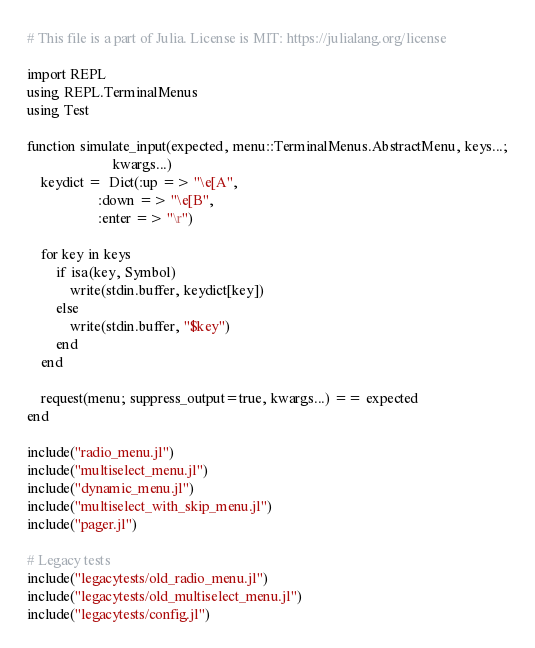Convert code to text. <code><loc_0><loc_0><loc_500><loc_500><_Julia_># This file is a part of Julia. License is MIT: https://julialang.org/license

import REPL
using REPL.TerminalMenus
using Test

function simulate_input(expected, menu::TerminalMenus.AbstractMenu, keys...;
                        kwargs...)
    keydict =  Dict(:up => "\e[A",
                    :down => "\e[B",
                    :enter => "\r")

    for key in keys
        if isa(key, Symbol)
            write(stdin.buffer, keydict[key])
        else
            write(stdin.buffer, "$key")
        end
    end

    request(menu; suppress_output=true, kwargs...) == expected
end

include("radio_menu.jl")
include("multiselect_menu.jl")
include("dynamic_menu.jl")
include("multiselect_with_skip_menu.jl")
include("pager.jl")

# Legacy tests
include("legacytests/old_radio_menu.jl")
include("legacytests/old_multiselect_menu.jl")
include("legacytests/config.jl")
</code> 